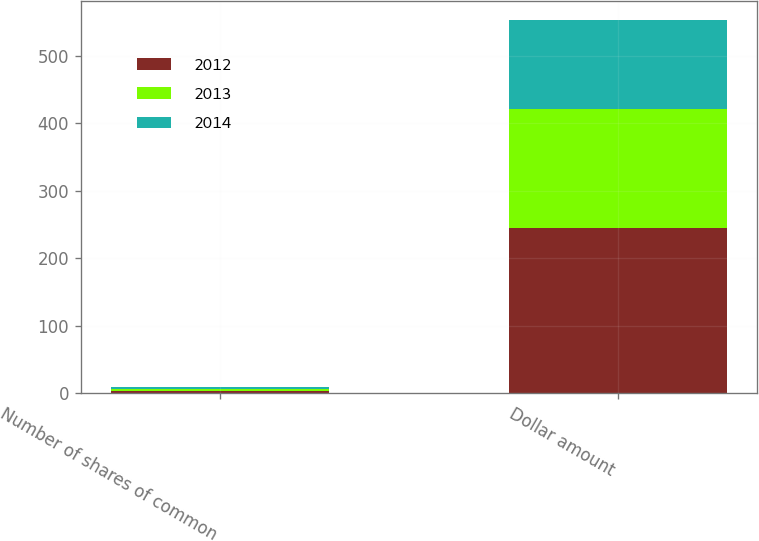Convert chart. <chart><loc_0><loc_0><loc_500><loc_500><stacked_bar_chart><ecel><fcel>Number of shares of common<fcel>Dollar amount<nl><fcel>2012<fcel>3.6<fcel>244.3<nl><fcel>2013<fcel>2.7<fcel>177.4<nl><fcel>2014<fcel>2.4<fcel>132.2<nl></chart> 